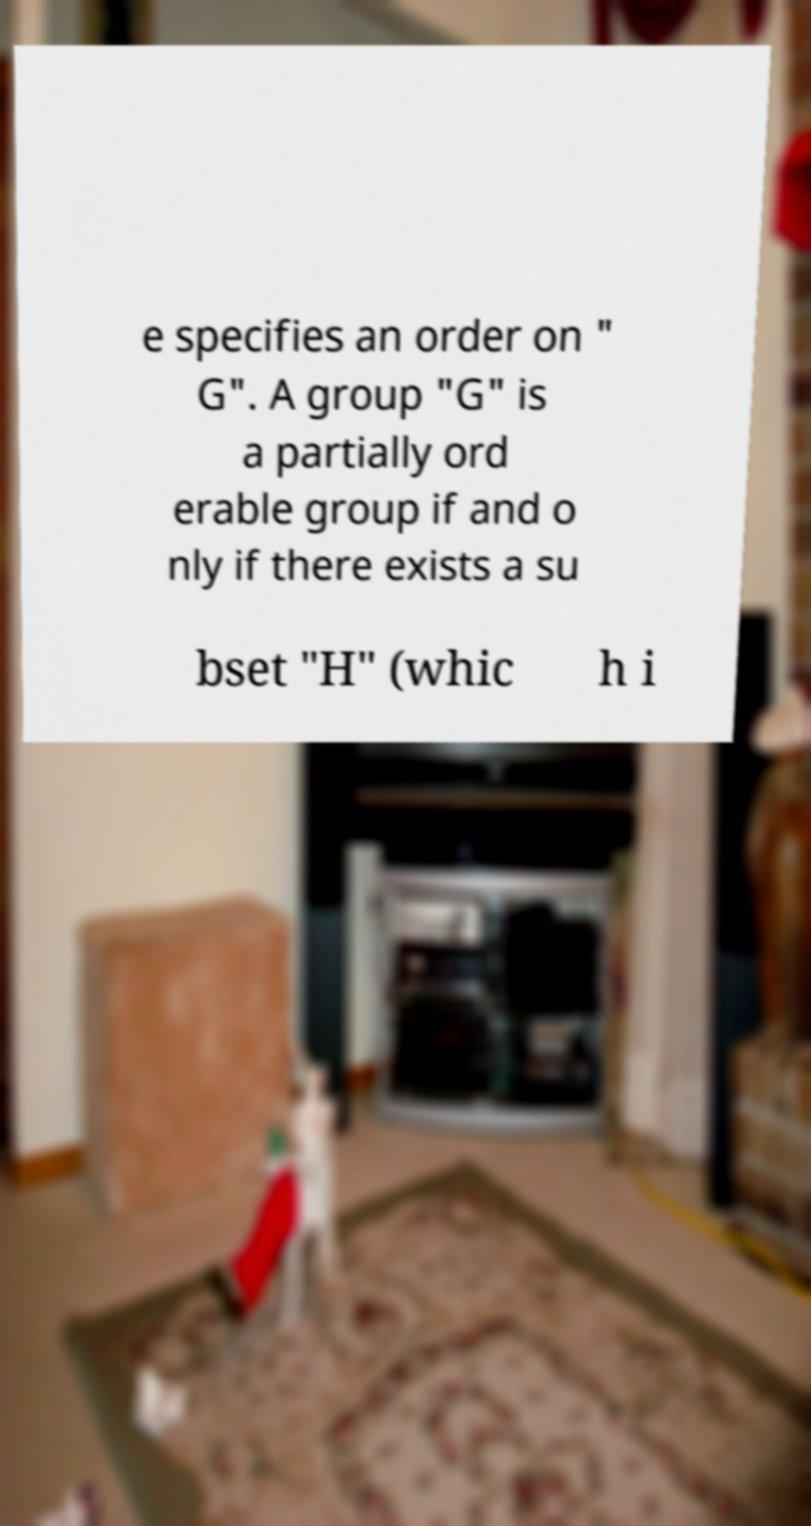Could you extract and type out the text from this image? e specifies an order on " G". A group "G" is a partially ord erable group if and o nly if there exists a su bset "H" (whic h i 